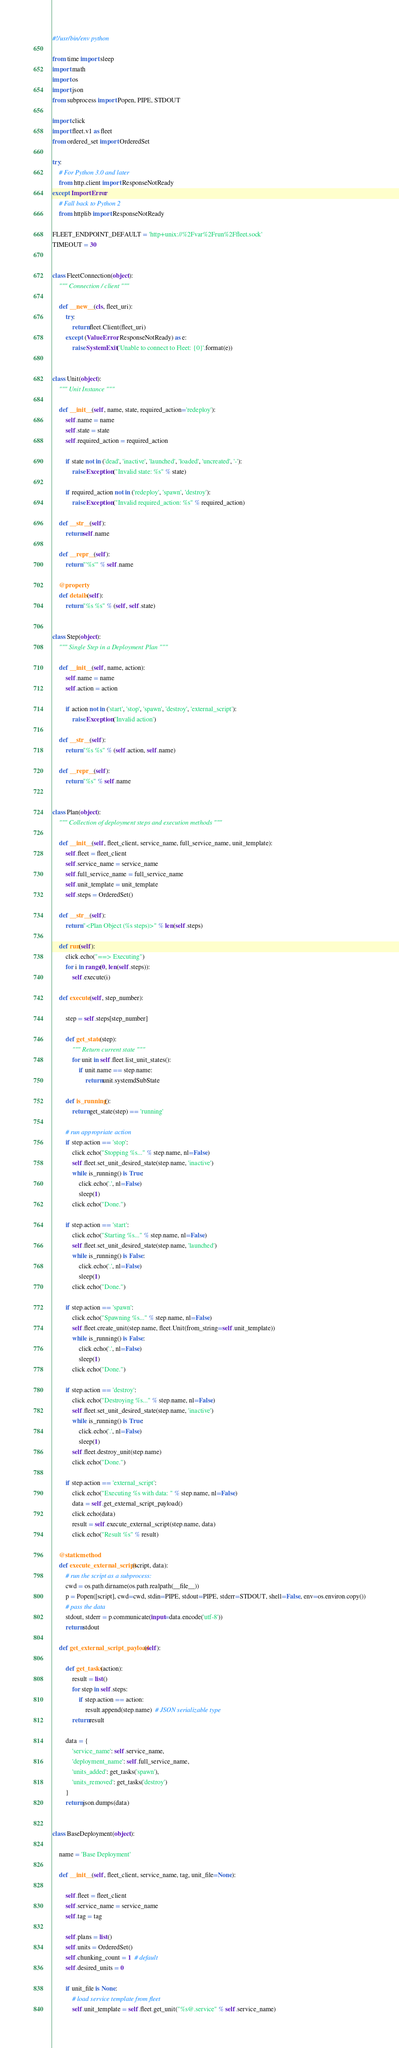Convert code to text. <code><loc_0><loc_0><loc_500><loc_500><_Python_>#!/usr/bin/env python

from time import sleep
import math
import os
import json
from subprocess import Popen, PIPE, STDOUT

import click
import fleet.v1 as fleet
from ordered_set import OrderedSet

try:
    # For Python 3.0 and later
    from http.client import ResponseNotReady
except ImportError:
    # Fall back to Python 2
    from httplib import ResponseNotReady

FLEET_ENDPOINT_DEFAULT = 'http+unix://%2Fvar%2Frun%2Ffleet.sock'
TIMEOUT = 30


class FleetConnection(object):
    """ Connection / client """

    def __new__(cls, fleet_uri):
        try:
            return fleet.Client(fleet_uri)
        except (ValueError, ResponseNotReady) as e:
            raise SystemExit('Unable to connect to Fleet: {0}'.format(e))


class Unit(object):
    """ Unit Instance """

    def __init__(self, name, state, required_action='redeploy'):
        self.name = name
        self.state = state
        self.required_action = required_action

        if state not in ('dead', 'inactive', 'launched', 'loaded', 'uncreated', '-'):
            raise Exception("Invalid state: %s" % state)

        if required_action not in ('redeploy', 'spawn', 'destroy'):
            raise Exception("Invalid required_action: %s" % required_action)

    def __str__(self):
        return self.name

    def __repr__(self):
        return "'%s'" % self.name

    @property
    def details(self):
        return "%s %s" % (self, self.state)


class Step(object):
    """ Single Step in a Deployment Plan """

    def __init__(self, name, action):
        self.name = name
        self.action = action

        if action not in ('start', 'stop', 'spawn', 'destroy', 'external_script'):
            raise Exception('Invalid action')

    def __str__(self):
        return "%s %s" % (self.action, self.name)

    def __repr__(self):
        return "%s" % self.name


class Plan(object):
    """ Collection of deployment steps and execution methods """

    def __init__(self, fleet_client, service_name, full_service_name, unit_template):
        self.fleet = fleet_client
        self.service_name = service_name
        self.full_service_name = full_service_name
        self.unit_template = unit_template
        self.steps = OrderedSet()

    def __str__(self):
        return "<Plan Object (%s steps)>" % len(self.steps)

    def run(self):
        click.echo("==> Executing")
        for i in range(0, len(self.steps)):
            self.execute(i)

    def execute(self, step_number):

        step = self.steps[step_number]

        def get_state(step):
            """ Return current state """
            for unit in self.fleet.list_unit_states():
                if unit.name == step.name:
                    return unit.systemdSubState

        def is_running():
            return get_state(step) == 'running'

        # run appropriate action
        if step.action == 'stop':
            click.echo("Stopping %s..." % step.name, nl=False)
            self.fleet.set_unit_desired_state(step.name, 'inactive')
            while is_running() is True:
                click.echo('.', nl=False)
                sleep(1)
            click.echo("Done.")

        if step.action == 'start':
            click.echo("Starting %s..." % step.name, nl=False)
            self.fleet.set_unit_desired_state(step.name, 'launched')
            while is_running() is False:
                click.echo('.', nl=False)
                sleep(1)
            click.echo("Done.")

        if step.action == 'spawn':
            click.echo("Spawning %s..." % step.name, nl=False)
            self.fleet.create_unit(step.name, fleet.Unit(from_string=self.unit_template))
            while is_running() is False:
                click.echo('.', nl=False)
                sleep(1)
            click.echo("Done.")

        if step.action == 'destroy':
            click.echo("Destroying %s..." % step.name, nl=False)
            self.fleet.set_unit_desired_state(step.name, 'inactive')
            while is_running() is True:
                click.echo('.', nl=False)
                sleep(1)
            self.fleet.destroy_unit(step.name)
            click.echo("Done.")

        if step.action == 'external_script':
            click.echo("Executing %s with data: " % step.name, nl=False)
            data = self.get_external_script_payload()
            click.echo(data)
            result = self.execute_external_script(step.name, data)
            click.echo("Result %s" % result)

    @staticmethod
    def execute_external_script(script, data):
        # run the script as a subprocess:
        cwd = os.path.dirname(os.path.realpath(__file__))
        p = Popen([script], cwd=cwd, stdin=PIPE, stdout=PIPE, stderr=STDOUT, shell=False, env=os.environ.copy())
        # pass the data
        stdout, stderr = p.communicate(input=data.encode('utf-8'))
        return stdout

    def get_external_script_payload(self):

        def get_tasks(action):
            result = list()
            for step in self.steps:
                if step.action == action:
                    result.append(step.name)  # JSON serializable type
            return result

        data = {
            'service_name': self.service_name,
            'deployment_name': self.full_service_name,
            'units_added': get_tasks('spawn'),
            'units_removed': get_tasks('destroy')
        }
        return json.dumps(data)


class BaseDeployment(object):

    name = 'Base Deployment'

    def __init__(self, fleet_client, service_name, tag, unit_file=None):

        self.fleet = fleet_client
        self.service_name = service_name
        self.tag = tag

        self.plans = list()
        self.units = OrderedSet()
        self.chunking_count = 1  # default
        self.desired_units = 0

        if unit_file is None:
            # load service template from fleet
            self.unit_template = self.fleet.get_unit("%s@.service" % self.service_name)</code> 